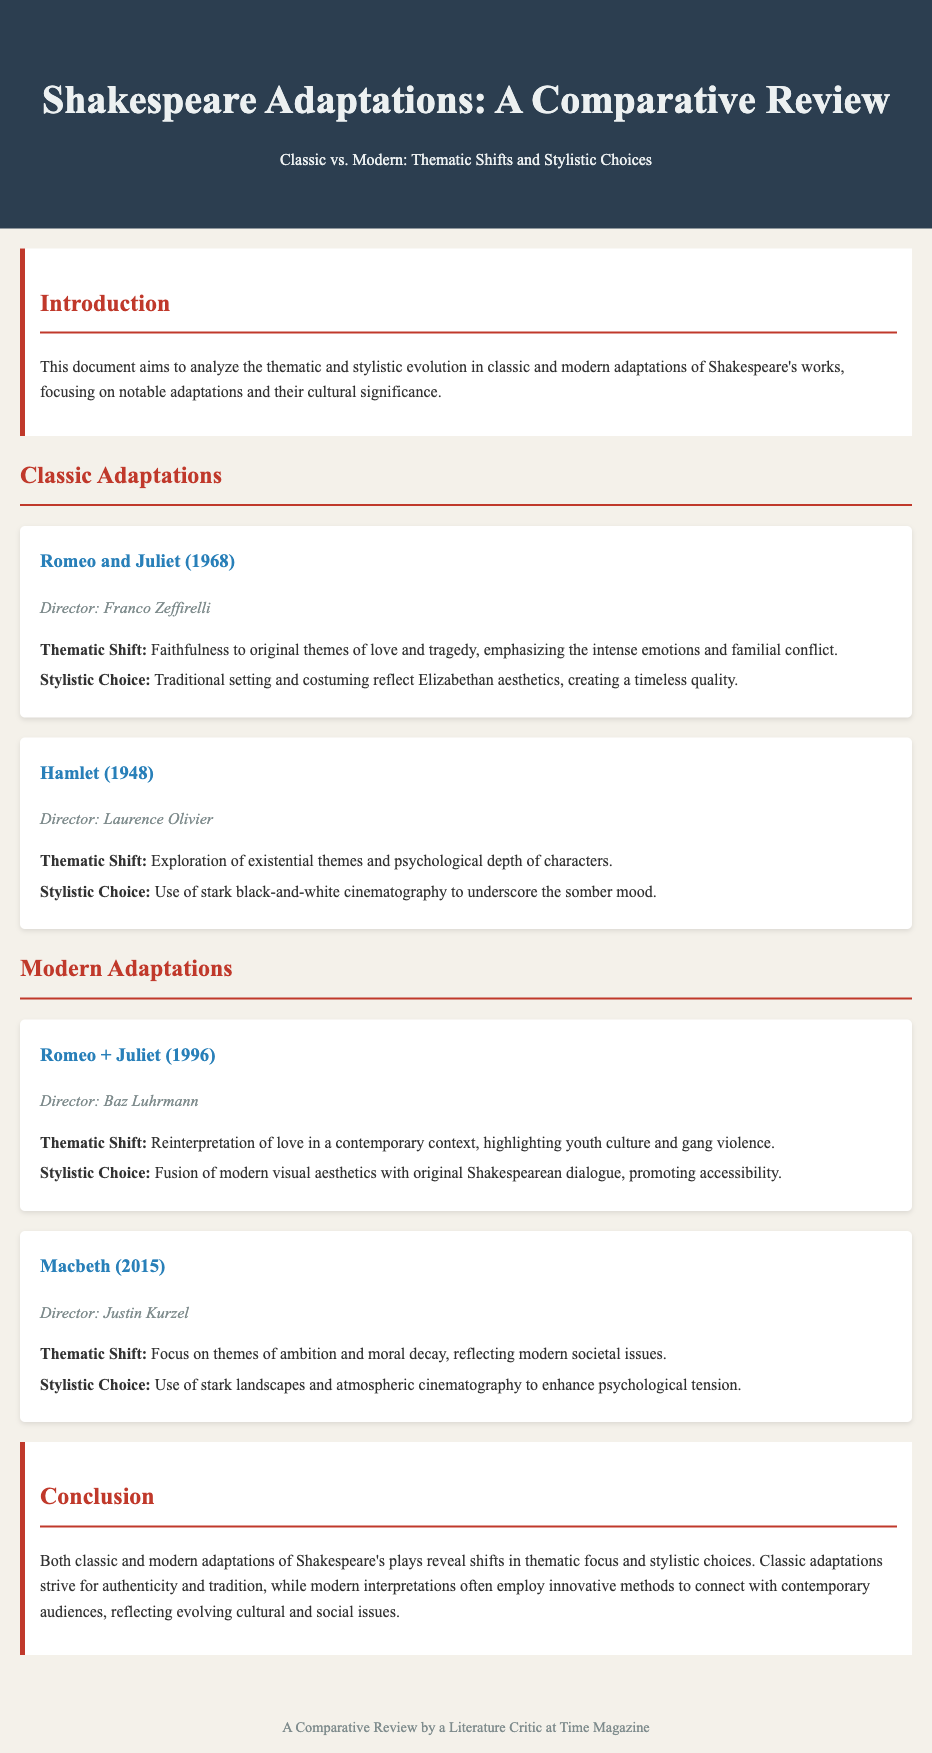What is the title of the document? The title of the document is specified in the header section, indicating the primary subject matter of the review.
Answer: Shakespeare Adaptations: A Comparative Review Who directed Romeo and Juliet (1968)? The document provides specific details about the director of the classic adaptation mentioned.
Answer: Franco Zeffirelli What major thematic shift is noted in Romeo + Juliet (1996)? The thematic shift in this modern adaptation is highlighted in the analysis section detailing its focus.
Answer: Youth culture and gang violence What year was Hamlet directed by Laurence Olivier? This information is listed under the classic adaptations section with the adaptation title.
Answer: 1948 Which adaptation emphasizes existential themes? The document explicitly lists thematic focuses for classic adaptations, noting this specific one.
Answer: Hamlet (1948) What is the concluding observation regarding classic and modern adaptations? The conclusion section summarizes the overall findings about the adaptations' thematic and stylistic differences.
Answer: Shifts in thematic focus and stylistic choices What type of cinematography is used in Macbeth (2015)? The stylistic choice is listed under the modern adaptations section, revealing the visual approach taken.
Answer: Atmospheric cinematography How does the document describe classic adaptations in terms of authenticity? The document articulates the approach of classic adaptations, emphasizing their characteristic features regarding tradition.
Answer: Strive for authenticity and tradition What element of visual aesthetics is noted in Romeo + Juliet (1996)? The stylistic choice mentioned indicates the fusion of contemporary styles with Shakespeare's original text.
Answer: Modern visual aesthetics 